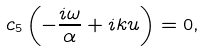<formula> <loc_0><loc_0><loc_500><loc_500>c _ { 5 } \left ( - \frac { i \omega } { \alpha } + i k u \right ) = 0 ,</formula> 